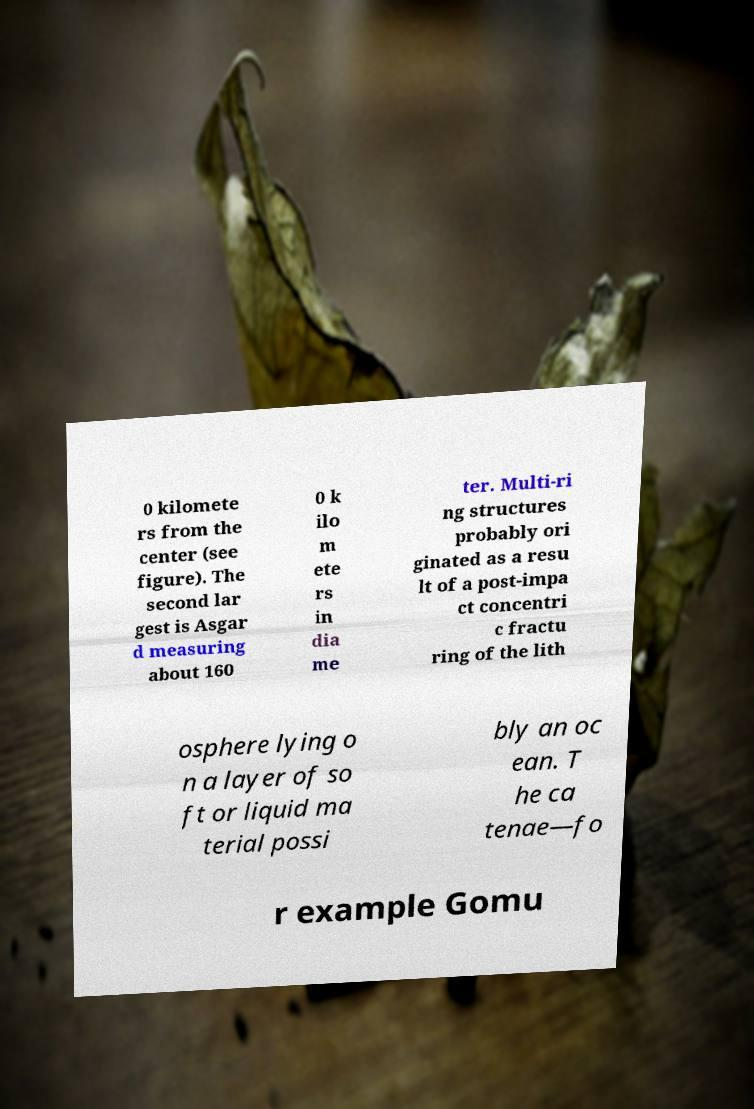Could you extract and type out the text from this image? 0 kilomete rs from the center (see figure). The second lar gest is Asgar d measuring about 160 0 k ilo m ete rs in dia me ter. Multi-ri ng structures probably ori ginated as a resu lt of a post-impa ct concentri c fractu ring of the lith osphere lying o n a layer of so ft or liquid ma terial possi bly an oc ean. T he ca tenae—fo r example Gomu 